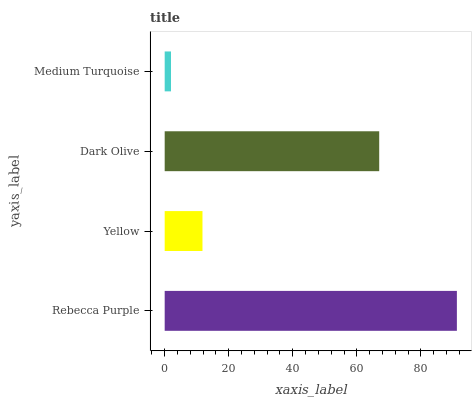Is Medium Turquoise the minimum?
Answer yes or no. Yes. Is Rebecca Purple the maximum?
Answer yes or no. Yes. Is Yellow the minimum?
Answer yes or no. No. Is Yellow the maximum?
Answer yes or no. No. Is Rebecca Purple greater than Yellow?
Answer yes or no. Yes. Is Yellow less than Rebecca Purple?
Answer yes or no. Yes. Is Yellow greater than Rebecca Purple?
Answer yes or no. No. Is Rebecca Purple less than Yellow?
Answer yes or no. No. Is Dark Olive the high median?
Answer yes or no. Yes. Is Yellow the low median?
Answer yes or no. Yes. Is Yellow the high median?
Answer yes or no. No. Is Rebecca Purple the low median?
Answer yes or no. No. 